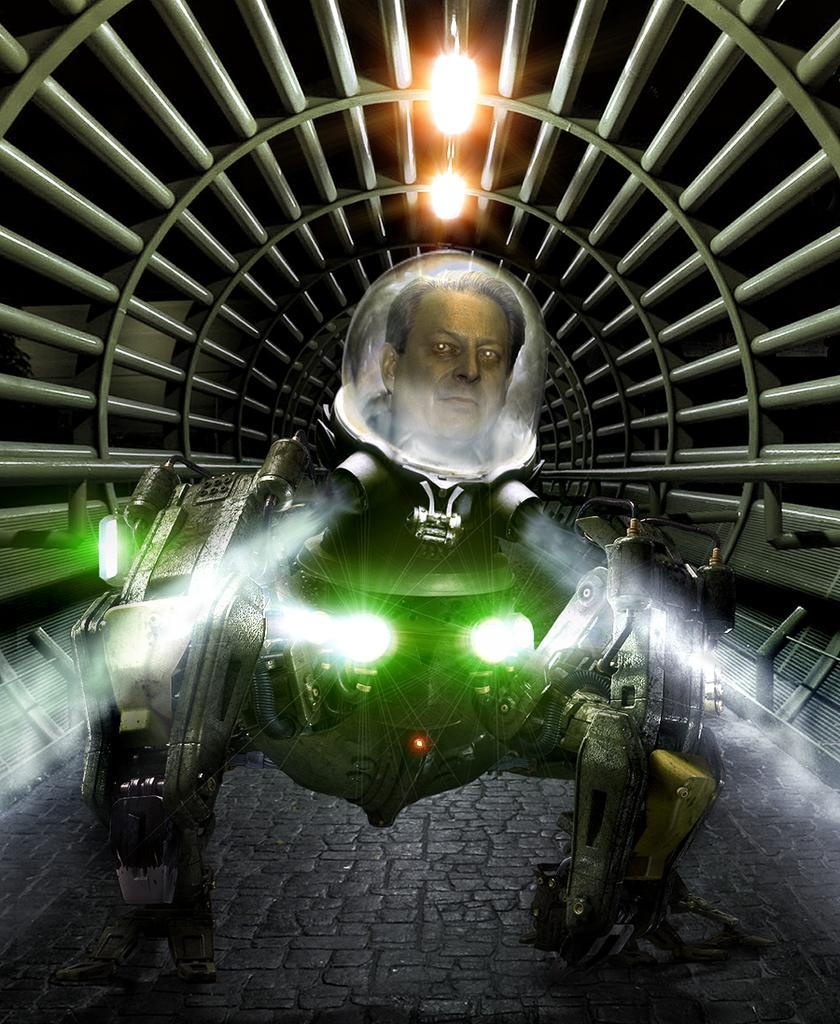What type of object is in the picture? There is an electronic machine in the picture. Can you describe any human features in the image? A woman's face is visible in the picture. What else can be seen in the picture besides the electronic machine and the woman's face? There are lights and a tunnel in the picture. Can you hear the monkey honking its horn while jumping in the picture? There is no monkey or horn present in the image, so it is not possible to hear any honking or see any jumping. 